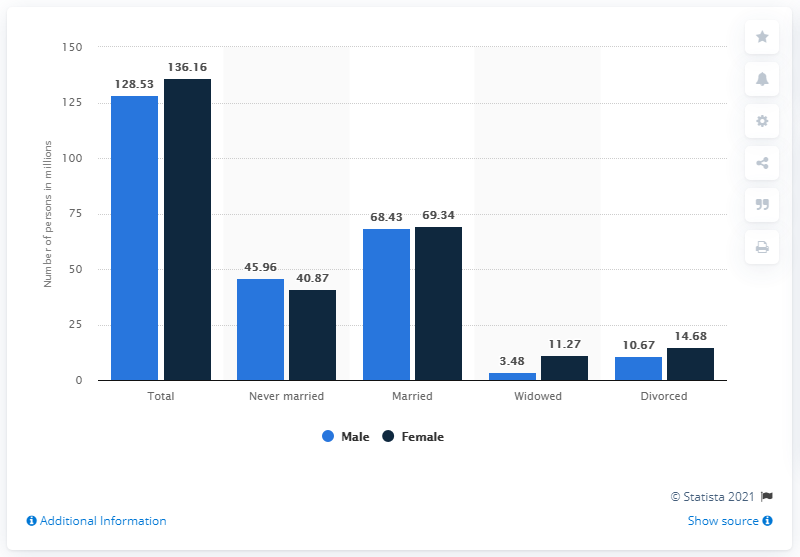Draw attention to some important aspects in this diagram. In the United States in 2020, there were 69.34 married women. According to the data, there are more female married people in the US than male married people. In 2020, there were approximately 3.48 million widowed men in the United States. In 2020, it is estimated that 68.43% of men in the United States were married. The marital status category with the least difference between the male and female population is "Married. 